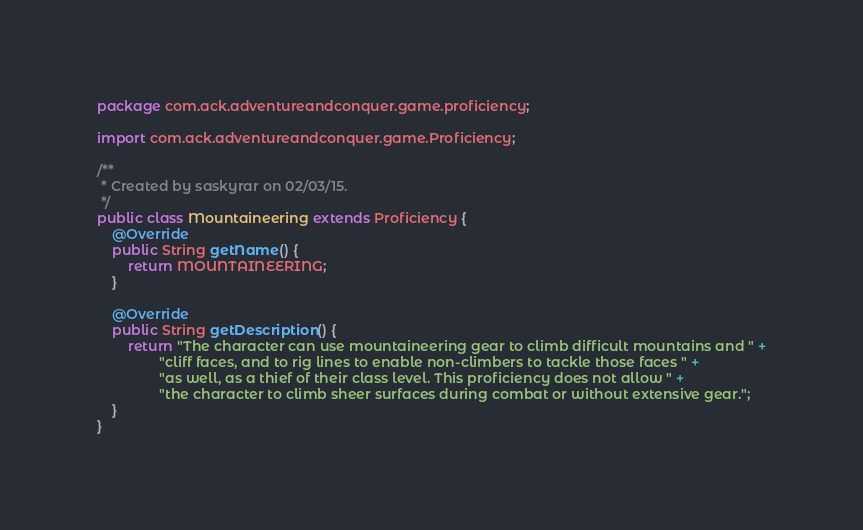Convert code to text. <code><loc_0><loc_0><loc_500><loc_500><_Java_>package com.ack.adventureandconquer.game.proficiency;

import com.ack.adventureandconquer.game.Proficiency;

/**
 * Created by saskyrar on 02/03/15.
 */
public class Mountaineering extends Proficiency {
    @Override
    public String getName() {
        return MOUNTAINEERING;
    }

    @Override
    public String getDescription() {
        return "The character can use mountaineering gear to climb difficult mountains and " +
                "cliff faces, and to rig lines to enable non-climbers to tackle those faces " +
                "as well, as a thief of their class level. This proficiency does not allow " +
                "the character to climb sheer surfaces during combat or without extensive gear.";
    }
}
</code> 